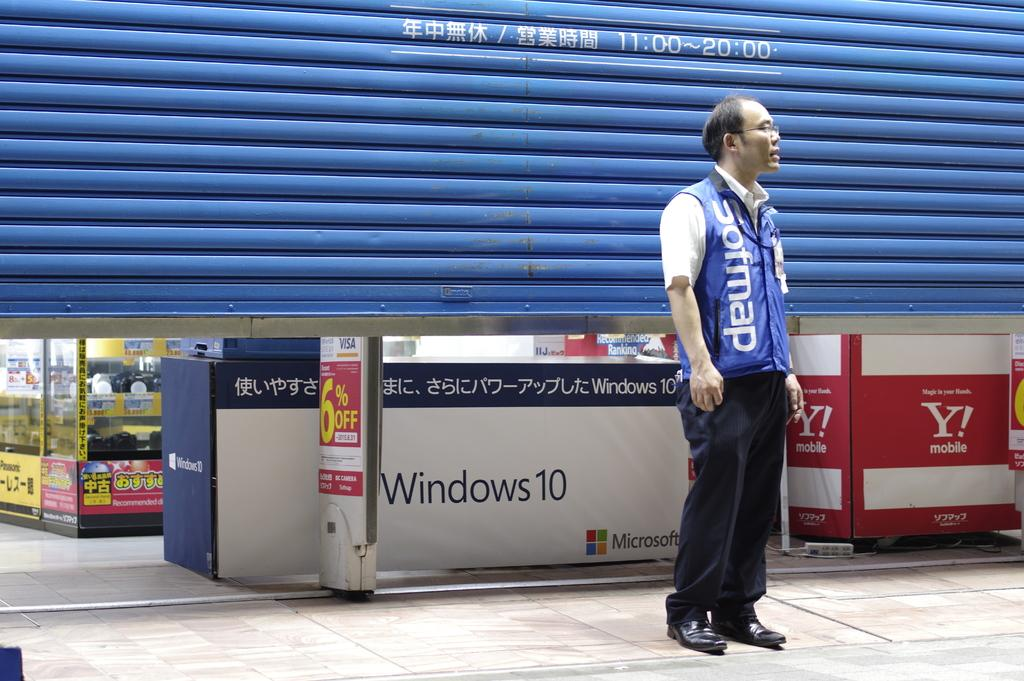What is the main subject of the image? The main subject of the image is the backside of a store. What feature can be seen on the store in the image? There is a blue shutter on the store in the image. Is there a person visible in the image? Yes, a person is standing in the middle of the image. What is the person wearing? The person is wearing a blue coat. Can you tell me which chess piece the person is holding in the image? There is no chess piece visible in the image, nor is there any indication that the person is holding one. 